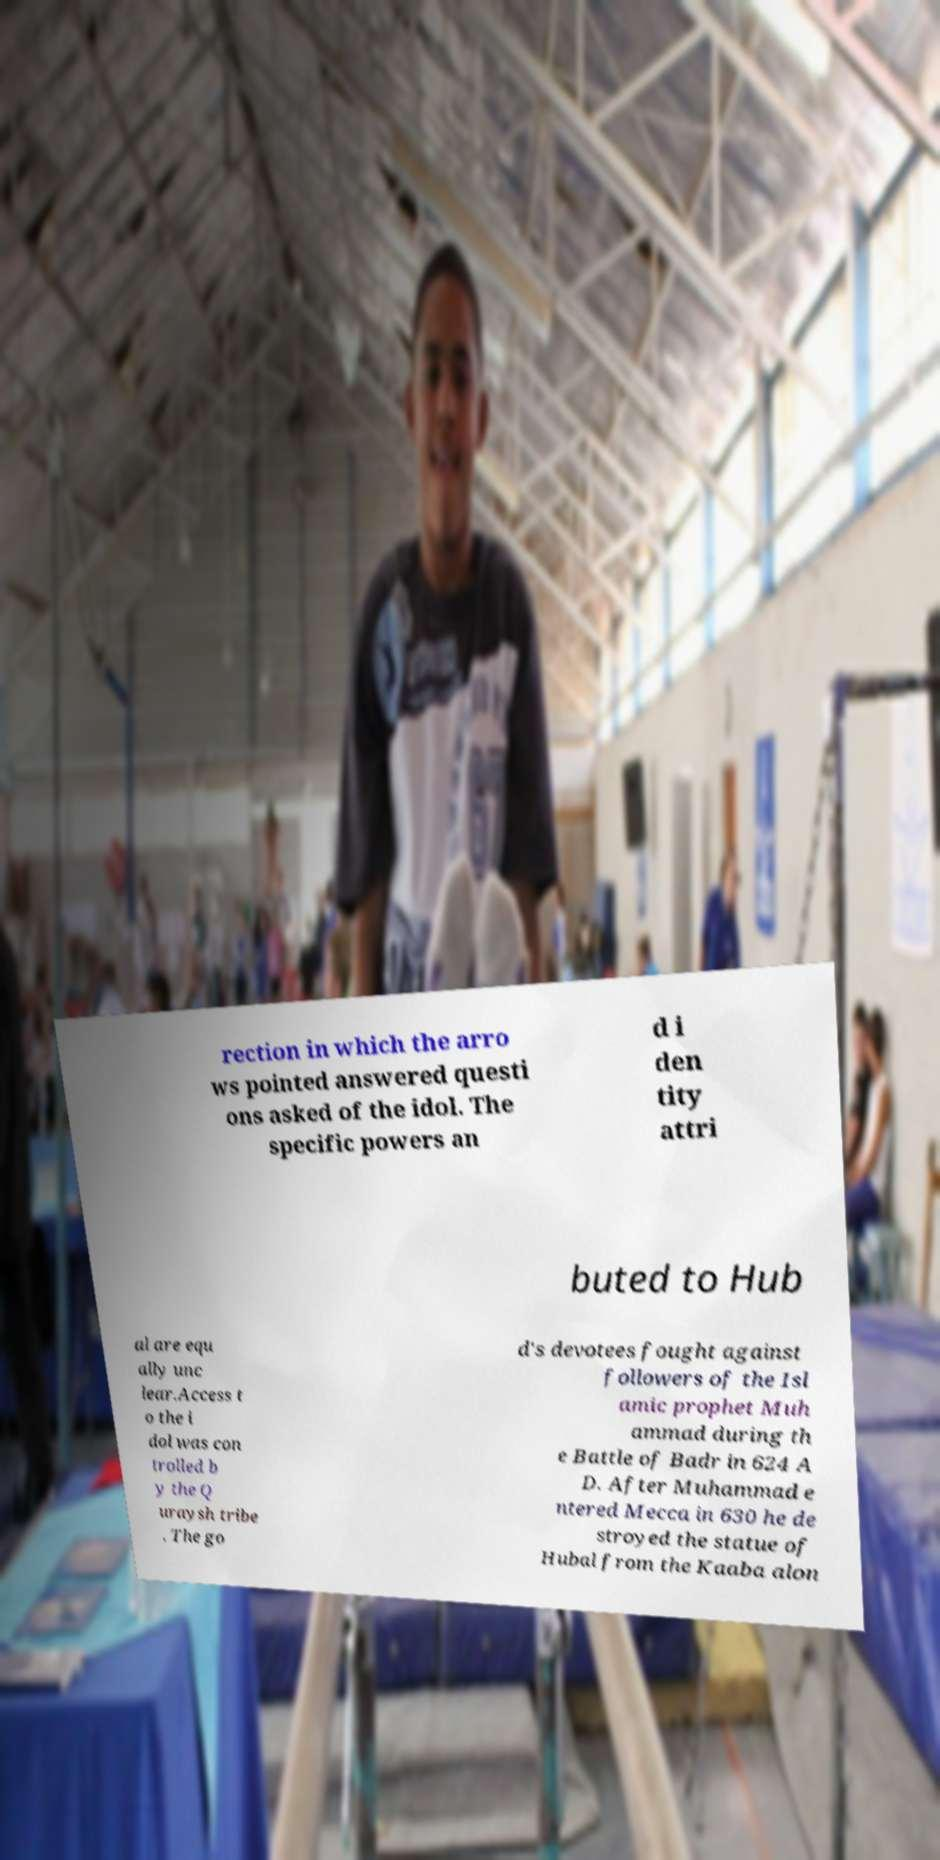Could you extract and type out the text from this image? rection in which the arro ws pointed answered questi ons asked of the idol. The specific powers an d i den tity attri buted to Hub al are equ ally unc lear.Access t o the i dol was con trolled b y the Q uraysh tribe . The go d's devotees fought against followers of the Isl amic prophet Muh ammad during th e Battle of Badr in 624 A D. After Muhammad e ntered Mecca in 630 he de stroyed the statue of Hubal from the Kaaba alon 